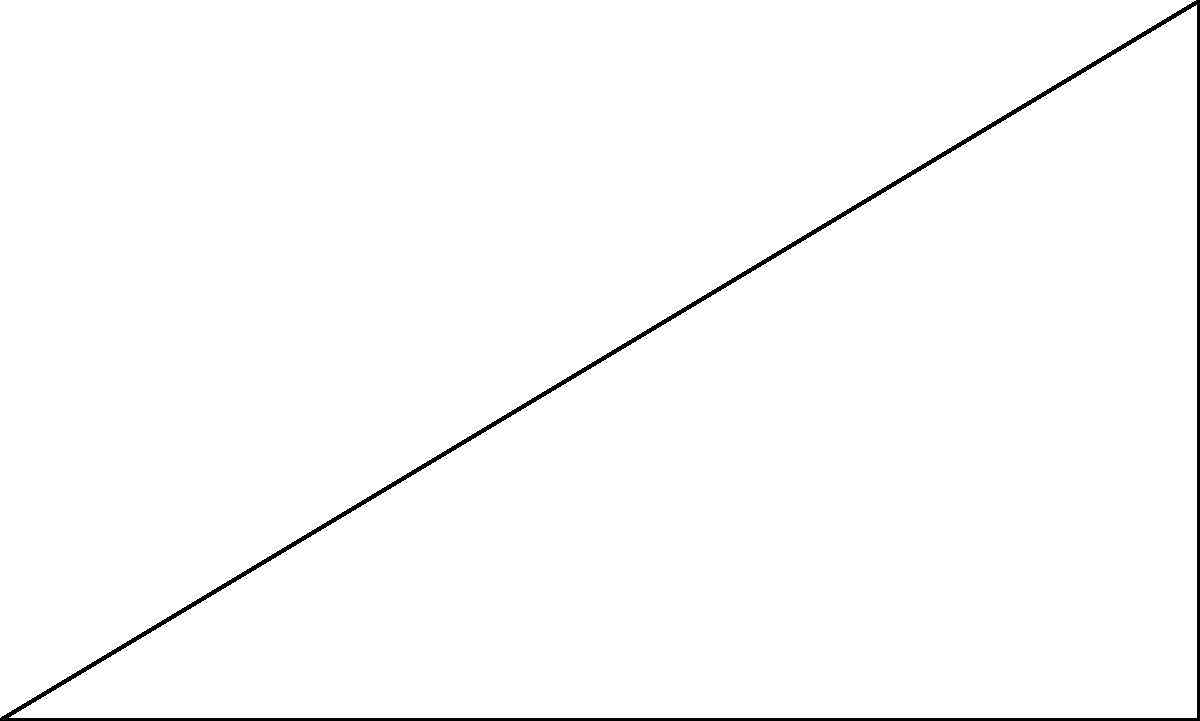An artillery unit needs to calculate the angle of elevation for their cannon to hit a target on higher ground. The horizontal distance to the target is 300 meters, and the target is 180 meters above the cannon's position. What is the angle of elevation (θ) required for the cannon? To solve this problem, we'll use the principles of right-angled trigonometry:

1. Identify the triangle:
   - The horizontal distance forms the base (adjacent side)
   - The height difference forms the vertical side (opposite side)
   - The line of sight to the target forms the hypotenuse

2. Determine which trigonometric ratio to use:
   - We need to find the angle given the opposite and adjacent sides
   - This calls for the tangent function

3. Set up the equation:
   $$\tan \theta = \frac{\text{opposite}}{\text{adjacent}} = \frac{180}{300}$$

4. Solve for θ:
   $$\theta = \tan^{-1}\left(\frac{180}{300}\right)$$

5. Calculate the result:
   $$\theta = \tan^{-1}(0.6) \approx 30.96^\circ$$

6. Round to a practical precision for artillery (nearest tenth of a degree):
   $$\theta \approx 31.0^\circ$$

This angle of elevation will allow the artillery unit to accurately target the position on higher ground.
Answer: $31.0^\circ$ 